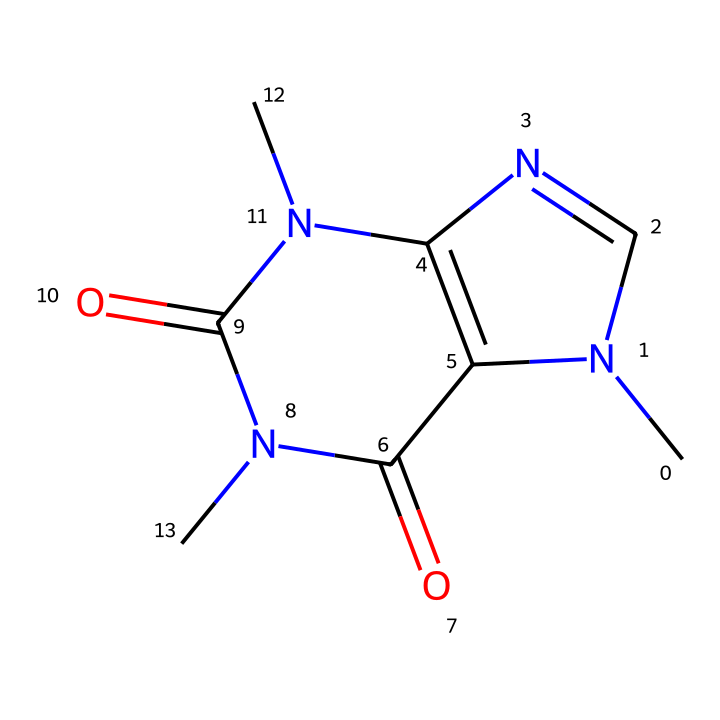What is the chemical name of this compound? The given SMILES representation corresponds to the structure for caffeine, a well-known stimulant commonly found in energy drinks.
Answer: caffeine How many nitrogen atoms are present in the compound? By examining the structure indicated by the SMILES, we can count three nitrogen atoms present in the ring system.
Answer: three What type of compound is caffeine categorized as? Caffeine is classified as an alkaloid, which is a class of naturally occurring organic compounds that mostly contain basic nitrogen atoms.
Answer: alkaloid How many rings are present in the structure of caffeine? The visual representation of the chemical shows two interconnected aromatic rings, which is characteristic of caffeine's bicyclic structure.
Answer: two What functional groups can be identified in the caffeine molecule? Analyzing the chemical structure, we identify that caffeine contains amine and carbonyl functional groups indicated by the nitrogen and carbonyl oxygens in the structure.
Answer: amine and carbonyl Does this compound contain any double bonds? The SMILES notation shows that there are double bonds in the carbon backbone, particularly in the rings, confirming the presence of π bonds.
Answer: yes 